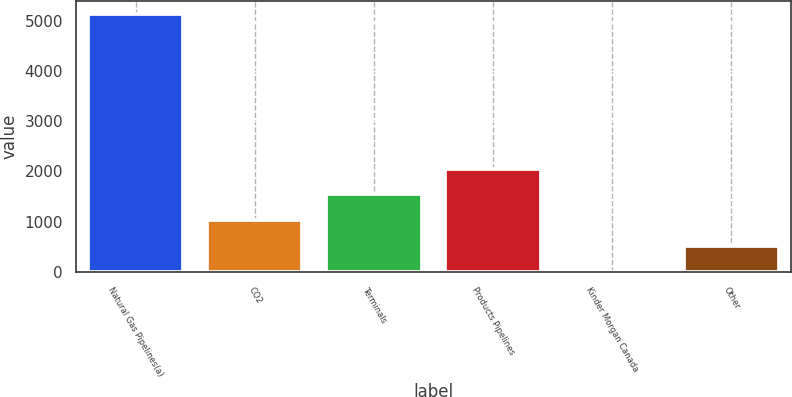Convert chart to OTSL. <chart><loc_0><loc_0><loc_500><loc_500><bar_chart><fcel>Natural Gas Pipelines(a)<fcel>CO2<fcel>Terminals<fcel>Products Pipelines<fcel>Kinder Morgan Canada<fcel>Other<nl><fcel>5130<fcel>1026.8<fcel>1539.7<fcel>2052.6<fcel>1<fcel>513.9<nl></chart> 